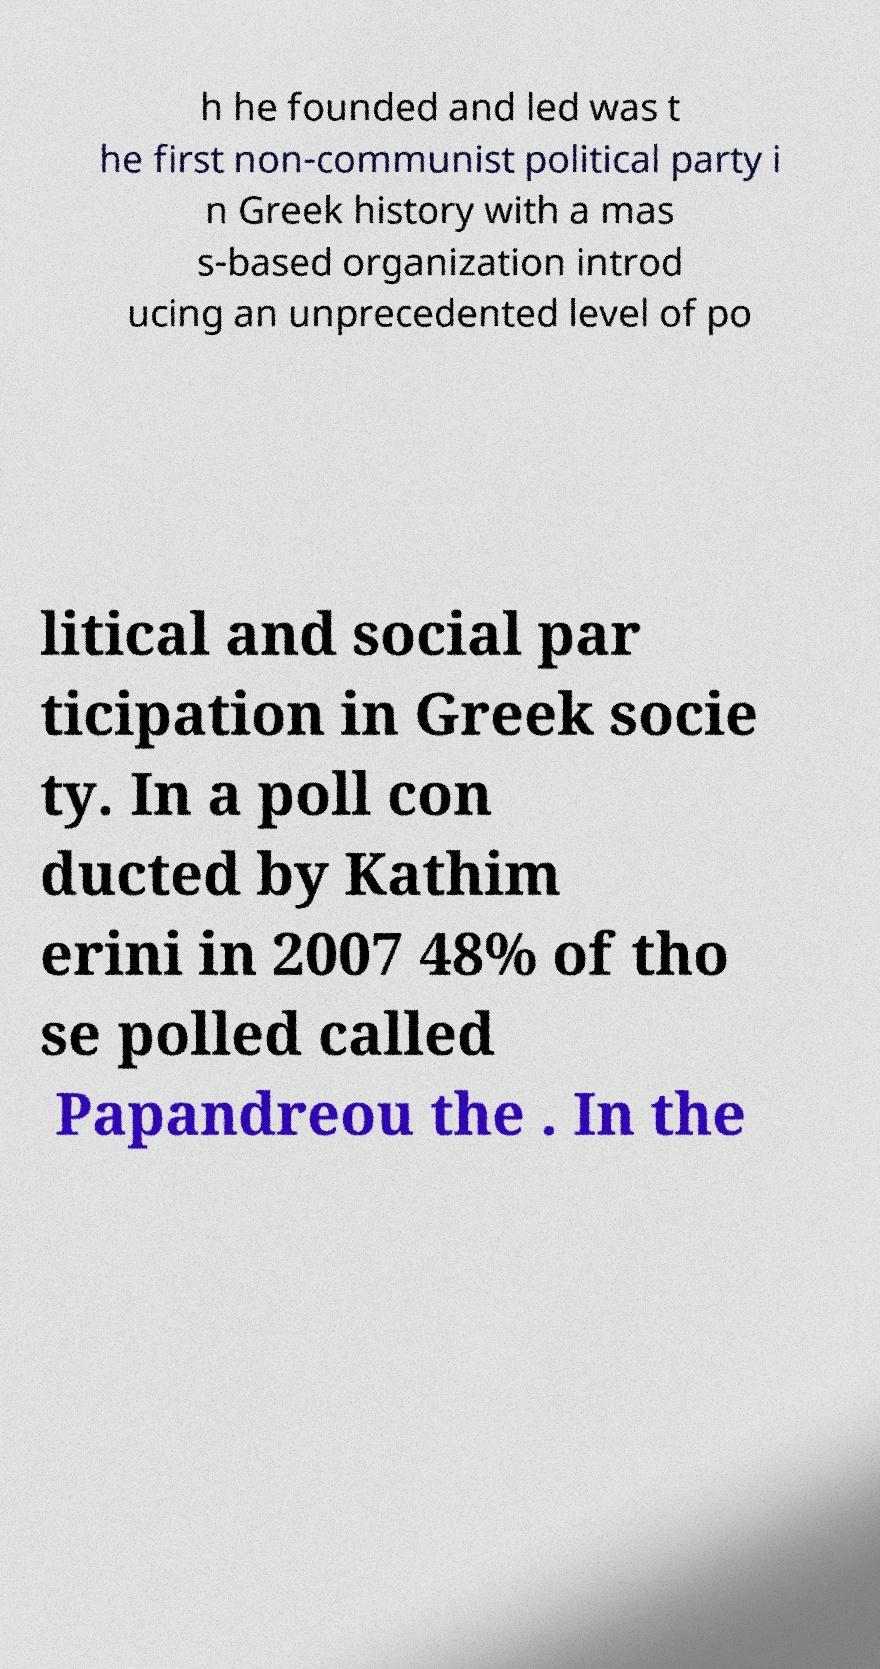Can you read and provide the text displayed in the image?This photo seems to have some interesting text. Can you extract and type it out for me? h he founded and led was t he first non-communist political party i n Greek history with a mas s-based organization introd ucing an unprecedented level of po litical and social par ticipation in Greek socie ty. In a poll con ducted by Kathim erini in 2007 48% of tho se polled called Papandreou the . In the 